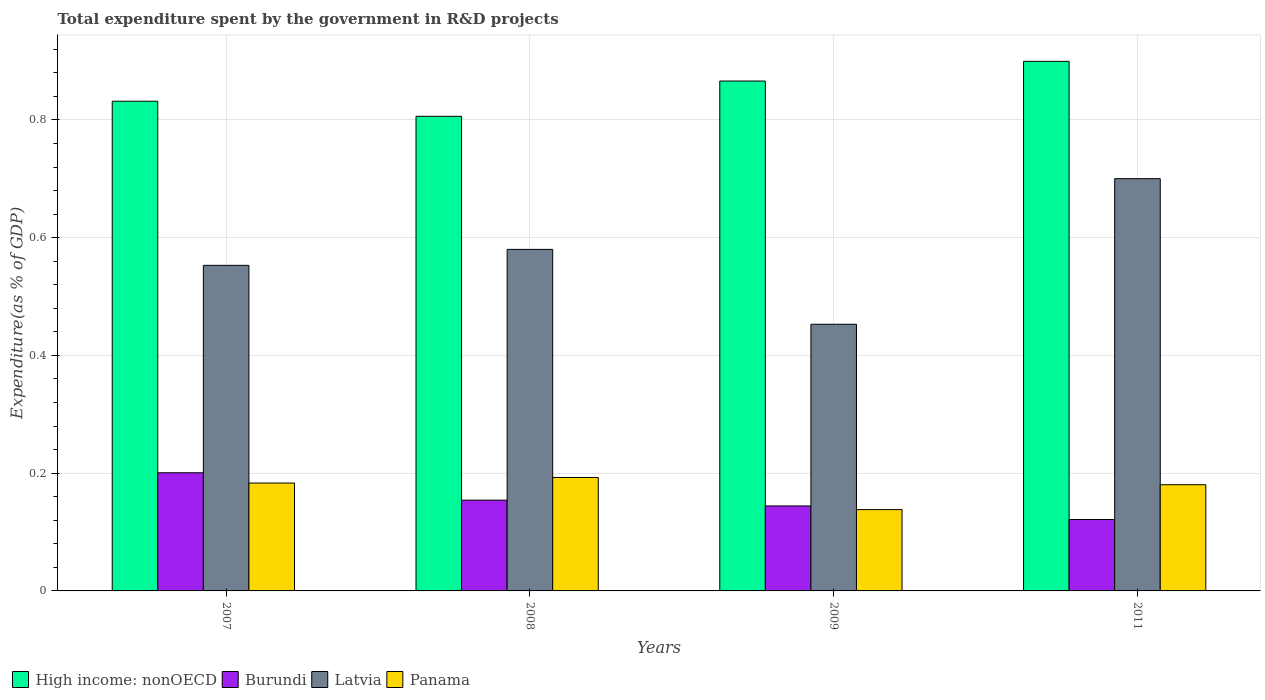Are the number of bars on each tick of the X-axis equal?
Your answer should be very brief. Yes. What is the label of the 1st group of bars from the left?
Give a very brief answer. 2007. What is the total expenditure spent by the government in R&D projects in Panama in 2007?
Your answer should be compact. 0.18. Across all years, what is the maximum total expenditure spent by the government in R&D projects in Latvia?
Your answer should be compact. 0.7. Across all years, what is the minimum total expenditure spent by the government in R&D projects in Panama?
Provide a succinct answer. 0.14. What is the total total expenditure spent by the government in R&D projects in Burundi in the graph?
Keep it short and to the point. 0.62. What is the difference between the total expenditure spent by the government in R&D projects in Panama in 2007 and that in 2011?
Provide a succinct answer. 0. What is the difference between the total expenditure spent by the government in R&D projects in High income: nonOECD in 2011 and the total expenditure spent by the government in R&D projects in Latvia in 2009?
Offer a very short reply. 0.45. What is the average total expenditure spent by the government in R&D projects in High income: nonOECD per year?
Offer a terse response. 0.85. In the year 2011, what is the difference between the total expenditure spent by the government in R&D projects in Burundi and total expenditure spent by the government in R&D projects in Latvia?
Offer a terse response. -0.58. What is the ratio of the total expenditure spent by the government in R&D projects in High income: nonOECD in 2007 to that in 2008?
Your answer should be very brief. 1.03. Is the total expenditure spent by the government in R&D projects in Latvia in 2007 less than that in 2009?
Give a very brief answer. No. What is the difference between the highest and the second highest total expenditure spent by the government in R&D projects in Latvia?
Ensure brevity in your answer.  0.12. What is the difference between the highest and the lowest total expenditure spent by the government in R&D projects in Panama?
Keep it short and to the point. 0.05. Is the sum of the total expenditure spent by the government in R&D projects in Latvia in 2009 and 2011 greater than the maximum total expenditure spent by the government in R&D projects in High income: nonOECD across all years?
Your response must be concise. Yes. Is it the case that in every year, the sum of the total expenditure spent by the government in R&D projects in High income: nonOECD and total expenditure spent by the government in R&D projects in Panama is greater than the sum of total expenditure spent by the government in R&D projects in Burundi and total expenditure spent by the government in R&D projects in Latvia?
Make the answer very short. No. What does the 2nd bar from the left in 2009 represents?
Provide a short and direct response. Burundi. What does the 4th bar from the right in 2011 represents?
Your answer should be very brief. High income: nonOECD. Are all the bars in the graph horizontal?
Offer a terse response. No. What is the difference between two consecutive major ticks on the Y-axis?
Offer a terse response. 0.2. Does the graph contain grids?
Provide a short and direct response. Yes. How many legend labels are there?
Offer a terse response. 4. What is the title of the graph?
Keep it short and to the point. Total expenditure spent by the government in R&D projects. What is the label or title of the Y-axis?
Keep it short and to the point. Expenditure(as % of GDP). What is the Expenditure(as % of GDP) in High income: nonOECD in 2007?
Make the answer very short. 0.83. What is the Expenditure(as % of GDP) of Burundi in 2007?
Keep it short and to the point. 0.2. What is the Expenditure(as % of GDP) of Latvia in 2007?
Make the answer very short. 0.55. What is the Expenditure(as % of GDP) in Panama in 2007?
Give a very brief answer. 0.18. What is the Expenditure(as % of GDP) in High income: nonOECD in 2008?
Your response must be concise. 0.81. What is the Expenditure(as % of GDP) of Burundi in 2008?
Your response must be concise. 0.15. What is the Expenditure(as % of GDP) in Latvia in 2008?
Make the answer very short. 0.58. What is the Expenditure(as % of GDP) in Panama in 2008?
Your response must be concise. 0.19. What is the Expenditure(as % of GDP) in High income: nonOECD in 2009?
Your answer should be compact. 0.87. What is the Expenditure(as % of GDP) of Burundi in 2009?
Ensure brevity in your answer.  0.14. What is the Expenditure(as % of GDP) of Latvia in 2009?
Your response must be concise. 0.45. What is the Expenditure(as % of GDP) in Panama in 2009?
Your answer should be compact. 0.14. What is the Expenditure(as % of GDP) in High income: nonOECD in 2011?
Give a very brief answer. 0.9. What is the Expenditure(as % of GDP) of Burundi in 2011?
Your answer should be compact. 0.12. What is the Expenditure(as % of GDP) of Latvia in 2011?
Ensure brevity in your answer.  0.7. What is the Expenditure(as % of GDP) in Panama in 2011?
Your response must be concise. 0.18. Across all years, what is the maximum Expenditure(as % of GDP) in High income: nonOECD?
Offer a terse response. 0.9. Across all years, what is the maximum Expenditure(as % of GDP) in Burundi?
Provide a succinct answer. 0.2. Across all years, what is the maximum Expenditure(as % of GDP) in Latvia?
Provide a short and direct response. 0.7. Across all years, what is the maximum Expenditure(as % of GDP) of Panama?
Offer a terse response. 0.19. Across all years, what is the minimum Expenditure(as % of GDP) of High income: nonOECD?
Give a very brief answer. 0.81. Across all years, what is the minimum Expenditure(as % of GDP) in Burundi?
Provide a short and direct response. 0.12. Across all years, what is the minimum Expenditure(as % of GDP) in Latvia?
Your answer should be compact. 0.45. Across all years, what is the minimum Expenditure(as % of GDP) of Panama?
Offer a terse response. 0.14. What is the total Expenditure(as % of GDP) in High income: nonOECD in the graph?
Offer a very short reply. 3.4. What is the total Expenditure(as % of GDP) of Burundi in the graph?
Make the answer very short. 0.62. What is the total Expenditure(as % of GDP) of Latvia in the graph?
Give a very brief answer. 2.29. What is the total Expenditure(as % of GDP) in Panama in the graph?
Make the answer very short. 0.69. What is the difference between the Expenditure(as % of GDP) in High income: nonOECD in 2007 and that in 2008?
Keep it short and to the point. 0.03. What is the difference between the Expenditure(as % of GDP) in Burundi in 2007 and that in 2008?
Ensure brevity in your answer.  0.05. What is the difference between the Expenditure(as % of GDP) of Latvia in 2007 and that in 2008?
Your response must be concise. -0.03. What is the difference between the Expenditure(as % of GDP) of Panama in 2007 and that in 2008?
Make the answer very short. -0.01. What is the difference between the Expenditure(as % of GDP) of High income: nonOECD in 2007 and that in 2009?
Provide a succinct answer. -0.03. What is the difference between the Expenditure(as % of GDP) in Burundi in 2007 and that in 2009?
Provide a short and direct response. 0.06. What is the difference between the Expenditure(as % of GDP) of Latvia in 2007 and that in 2009?
Provide a succinct answer. 0.1. What is the difference between the Expenditure(as % of GDP) in Panama in 2007 and that in 2009?
Make the answer very short. 0.05. What is the difference between the Expenditure(as % of GDP) in High income: nonOECD in 2007 and that in 2011?
Give a very brief answer. -0.07. What is the difference between the Expenditure(as % of GDP) of Burundi in 2007 and that in 2011?
Give a very brief answer. 0.08. What is the difference between the Expenditure(as % of GDP) in Latvia in 2007 and that in 2011?
Offer a very short reply. -0.15. What is the difference between the Expenditure(as % of GDP) of Panama in 2007 and that in 2011?
Provide a succinct answer. 0. What is the difference between the Expenditure(as % of GDP) in High income: nonOECD in 2008 and that in 2009?
Provide a succinct answer. -0.06. What is the difference between the Expenditure(as % of GDP) in Burundi in 2008 and that in 2009?
Provide a short and direct response. 0.01. What is the difference between the Expenditure(as % of GDP) of Latvia in 2008 and that in 2009?
Offer a terse response. 0.13. What is the difference between the Expenditure(as % of GDP) of Panama in 2008 and that in 2009?
Your response must be concise. 0.05. What is the difference between the Expenditure(as % of GDP) in High income: nonOECD in 2008 and that in 2011?
Your answer should be very brief. -0.09. What is the difference between the Expenditure(as % of GDP) of Burundi in 2008 and that in 2011?
Your answer should be very brief. 0.03. What is the difference between the Expenditure(as % of GDP) of Latvia in 2008 and that in 2011?
Your response must be concise. -0.12. What is the difference between the Expenditure(as % of GDP) of Panama in 2008 and that in 2011?
Your answer should be compact. 0.01. What is the difference between the Expenditure(as % of GDP) in High income: nonOECD in 2009 and that in 2011?
Provide a succinct answer. -0.03. What is the difference between the Expenditure(as % of GDP) in Burundi in 2009 and that in 2011?
Give a very brief answer. 0.02. What is the difference between the Expenditure(as % of GDP) in Latvia in 2009 and that in 2011?
Keep it short and to the point. -0.25. What is the difference between the Expenditure(as % of GDP) of Panama in 2009 and that in 2011?
Give a very brief answer. -0.04. What is the difference between the Expenditure(as % of GDP) in High income: nonOECD in 2007 and the Expenditure(as % of GDP) in Burundi in 2008?
Offer a terse response. 0.68. What is the difference between the Expenditure(as % of GDP) of High income: nonOECD in 2007 and the Expenditure(as % of GDP) of Latvia in 2008?
Offer a terse response. 0.25. What is the difference between the Expenditure(as % of GDP) of High income: nonOECD in 2007 and the Expenditure(as % of GDP) of Panama in 2008?
Your answer should be very brief. 0.64. What is the difference between the Expenditure(as % of GDP) in Burundi in 2007 and the Expenditure(as % of GDP) in Latvia in 2008?
Your answer should be compact. -0.38. What is the difference between the Expenditure(as % of GDP) in Burundi in 2007 and the Expenditure(as % of GDP) in Panama in 2008?
Offer a terse response. 0.01. What is the difference between the Expenditure(as % of GDP) of Latvia in 2007 and the Expenditure(as % of GDP) of Panama in 2008?
Your answer should be very brief. 0.36. What is the difference between the Expenditure(as % of GDP) in High income: nonOECD in 2007 and the Expenditure(as % of GDP) in Burundi in 2009?
Your answer should be compact. 0.69. What is the difference between the Expenditure(as % of GDP) in High income: nonOECD in 2007 and the Expenditure(as % of GDP) in Latvia in 2009?
Give a very brief answer. 0.38. What is the difference between the Expenditure(as % of GDP) of High income: nonOECD in 2007 and the Expenditure(as % of GDP) of Panama in 2009?
Your answer should be compact. 0.69. What is the difference between the Expenditure(as % of GDP) in Burundi in 2007 and the Expenditure(as % of GDP) in Latvia in 2009?
Offer a very short reply. -0.25. What is the difference between the Expenditure(as % of GDP) of Burundi in 2007 and the Expenditure(as % of GDP) of Panama in 2009?
Your answer should be very brief. 0.06. What is the difference between the Expenditure(as % of GDP) of Latvia in 2007 and the Expenditure(as % of GDP) of Panama in 2009?
Provide a short and direct response. 0.41. What is the difference between the Expenditure(as % of GDP) in High income: nonOECD in 2007 and the Expenditure(as % of GDP) in Burundi in 2011?
Offer a terse response. 0.71. What is the difference between the Expenditure(as % of GDP) of High income: nonOECD in 2007 and the Expenditure(as % of GDP) of Latvia in 2011?
Provide a short and direct response. 0.13. What is the difference between the Expenditure(as % of GDP) of High income: nonOECD in 2007 and the Expenditure(as % of GDP) of Panama in 2011?
Make the answer very short. 0.65. What is the difference between the Expenditure(as % of GDP) of Burundi in 2007 and the Expenditure(as % of GDP) of Latvia in 2011?
Ensure brevity in your answer.  -0.5. What is the difference between the Expenditure(as % of GDP) in Burundi in 2007 and the Expenditure(as % of GDP) in Panama in 2011?
Make the answer very short. 0.02. What is the difference between the Expenditure(as % of GDP) of Latvia in 2007 and the Expenditure(as % of GDP) of Panama in 2011?
Keep it short and to the point. 0.37. What is the difference between the Expenditure(as % of GDP) of High income: nonOECD in 2008 and the Expenditure(as % of GDP) of Burundi in 2009?
Ensure brevity in your answer.  0.66. What is the difference between the Expenditure(as % of GDP) of High income: nonOECD in 2008 and the Expenditure(as % of GDP) of Latvia in 2009?
Provide a succinct answer. 0.35. What is the difference between the Expenditure(as % of GDP) in High income: nonOECD in 2008 and the Expenditure(as % of GDP) in Panama in 2009?
Provide a short and direct response. 0.67. What is the difference between the Expenditure(as % of GDP) in Burundi in 2008 and the Expenditure(as % of GDP) in Latvia in 2009?
Ensure brevity in your answer.  -0.3. What is the difference between the Expenditure(as % of GDP) in Burundi in 2008 and the Expenditure(as % of GDP) in Panama in 2009?
Your answer should be very brief. 0.02. What is the difference between the Expenditure(as % of GDP) of Latvia in 2008 and the Expenditure(as % of GDP) of Panama in 2009?
Your answer should be compact. 0.44. What is the difference between the Expenditure(as % of GDP) in High income: nonOECD in 2008 and the Expenditure(as % of GDP) in Burundi in 2011?
Your answer should be compact. 0.68. What is the difference between the Expenditure(as % of GDP) in High income: nonOECD in 2008 and the Expenditure(as % of GDP) in Latvia in 2011?
Provide a short and direct response. 0.11. What is the difference between the Expenditure(as % of GDP) in High income: nonOECD in 2008 and the Expenditure(as % of GDP) in Panama in 2011?
Your answer should be compact. 0.63. What is the difference between the Expenditure(as % of GDP) of Burundi in 2008 and the Expenditure(as % of GDP) of Latvia in 2011?
Give a very brief answer. -0.55. What is the difference between the Expenditure(as % of GDP) of Burundi in 2008 and the Expenditure(as % of GDP) of Panama in 2011?
Keep it short and to the point. -0.03. What is the difference between the Expenditure(as % of GDP) of Latvia in 2008 and the Expenditure(as % of GDP) of Panama in 2011?
Ensure brevity in your answer.  0.4. What is the difference between the Expenditure(as % of GDP) of High income: nonOECD in 2009 and the Expenditure(as % of GDP) of Burundi in 2011?
Your response must be concise. 0.74. What is the difference between the Expenditure(as % of GDP) in High income: nonOECD in 2009 and the Expenditure(as % of GDP) in Latvia in 2011?
Your answer should be very brief. 0.17. What is the difference between the Expenditure(as % of GDP) of High income: nonOECD in 2009 and the Expenditure(as % of GDP) of Panama in 2011?
Your response must be concise. 0.69. What is the difference between the Expenditure(as % of GDP) of Burundi in 2009 and the Expenditure(as % of GDP) of Latvia in 2011?
Offer a terse response. -0.56. What is the difference between the Expenditure(as % of GDP) in Burundi in 2009 and the Expenditure(as % of GDP) in Panama in 2011?
Provide a succinct answer. -0.04. What is the difference between the Expenditure(as % of GDP) of Latvia in 2009 and the Expenditure(as % of GDP) of Panama in 2011?
Your answer should be very brief. 0.27. What is the average Expenditure(as % of GDP) of High income: nonOECD per year?
Give a very brief answer. 0.85. What is the average Expenditure(as % of GDP) of Burundi per year?
Provide a succinct answer. 0.16. What is the average Expenditure(as % of GDP) in Latvia per year?
Offer a terse response. 0.57. What is the average Expenditure(as % of GDP) of Panama per year?
Offer a terse response. 0.17. In the year 2007, what is the difference between the Expenditure(as % of GDP) in High income: nonOECD and Expenditure(as % of GDP) in Burundi?
Keep it short and to the point. 0.63. In the year 2007, what is the difference between the Expenditure(as % of GDP) of High income: nonOECD and Expenditure(as % of GDP) of Latvia?
Provide a succinct answer. 0.28. In the year 2007, what is the difference between the Expenditure(as % of GDP) in High income: nonOECD and Expenditure(as % of GDP) in Panama?
Your answer should be very brief. 0.65. In the year 2007, what is the difference between the Expenditure(as % of GDP) of Burundi and Expenditure(as % of GDP) of Latvia?
Provide a succinct answer. -0.35. In the year 2007, what is the difference between the Expenditure(as % of GDP) in Burundi and Expenditure(as % of GDP) in Panama?
Make the answer very short. 0.02. In the year 2007, what is the difference between the Expenditure(as % of GDP) in Latvia and Expenditure(as % of GDP) in Panama?
Keep it short and to the point. 0.37. In the year 2008, what is the difference between the Expenditure(as % of GDP) in High income: nonOECD and Expenditure(as % of GDP) in Burundi?
Keep it short and to the point. 0.65. In the year 2008, what is the difference between the Expenditure(as % of GDP) in High income: nonOECD and Expenditure(as % of GDP) in Latvia?
Make the answer very short. 0.23. In the year 2008, what is the difference between the Expenditure(as % of GDP) of High income: nonOECD and Expenditure(as % of GDP) of Panama?
Keep it short and to the point. 0.61. In the year 2008, what is the difference between the Expenditure(as % of GDP) in Burundi and Expenditure(as % of GDP) in Latvia?
Your answer should be very brief. -0.43. In the year 2008, what is the difference between the Expenditure(as % of GDP) of Burundi and Expenditure(as % of GDP) of Panama?
Provide a succinct answer. -0.04. In the year 2008, what is the difference between the Expenditure(as % of GDP) of Latvia and Expenditure(as % of GDP) of Panama?
Your response must be concise. 0.39. In the year 2009, what is the difference between the Expenditure(as % of GDP) in High income: nonOECD and Expenditure(as % of GDP) in Burundi?
Offer a terse response. 0.72. In the year 2009, what is the difference between the Expenditure(as % of GDP) of High income: nonOECD and Expenditure(as % of GDP) of Latvia?
Offer a terse response. 0.41. In the year 2009, what is the difference between the Expenditure(as % of GDP) of High income: nonOECD and Expenditure(as % of GDP) of Panama?
Offer a terse response. 0.73. In the year 2009, what is the difference between the Expenditure(as % of GDP) of Burundi and Expenditure(as % of GDP) of Latvia?
Make the answer very short. -0.31. In the year 2009, what is the difference between the Expenditure(as % of GDP) in Burundi and Expenditure(as % of GDP) in Panama?
Provide a succinct answer. 0.01. In the year 2009, what is the difference between the Expenditure(as % of GDP) in Latvia and Expenditure(as % of GDP) in Panama?
Give a very brief answer. 0.31. In the year 2011, what is the difference between the Expenditure(as % of GDP) of High income: nonOECD and Expenditure(as % of GDP) of Burundi?
Keep it short and to the point. 0.78. In the year 2011, what is the difference between the Expenditure(as % of GDP) of High income: nonOECD and Expenditure(as % of GDP) of Latvia?
Your answer should be very brief. 0.2. In the year 2011, what is the difference between the Expenditure(as % of GDP) in High income: nonOECD and Expenditure(as % of GDP) in Panama?
Make the answer very short. 0.72. In the year 2011, what is the difference between the Expenditure(as % of GDP) of Burundi and Expenditure(as % of GDP) of Latvia?
Offer a terse response. -0.58. In the year 2011, what is the difference between the Expenditure(as % of GDP) of Burundi and Expenditure(as % of GDP) of Panama?
Ensure brevity in your answer.  -0.06. In the year 2011, what is the difference between the Expenditure(as % of GDP) of Latvia and Expenditure(as % of GDP) of Panama?
Your answer should be compact. 0.52. What is the ratio of the Expenditure(as % of GDP) of High income: nonOECD in 2007 to that in 2008?
Give a very brief answer. 1.03. What is the ratio of the Expenditure(as % of GDP) of Burundi in 2007 to that in 2008?
Offer a terse response. 1.3. What is the ratio of the Expenditure(as % of GDP) of Latvia in 2007 to that in 2008?
Give a very brief answer. 0.95. What is the ratio of the Expenditure(as % of GDP) of Panama in 2007 to that in 2008?
Provide a short and direct response. 0.95. What is the ratio of the Expenditure(as % of GDP) in High income: nonOECD in 2007 to that in 2009?
Offer a terse response. 0.96. What is the ratio of the Expenditure(as % of GDP) in Burundi in 2007 to that in 2009?
Your answer should be compact. 1.39. What is the ratio of the Expenditure(as % of GDP) of Latvia in 2007 to that in 2009?
Provide a succinct answer. 1.22. What is the ratio of the Expenditure(as % of GDP) of Panama in 2007 to that in 2009?
Offer a terse response. 1.33. What is the ratio of the Expenditure(as % of GDP) in High income: nonOECD in 2007 to that in 2011?
Give a very brief answer. 0.92. What is the ratio of the Expenditure(as % of GDP) in Burundi in 2007 to that in 2011?
Give a very brief answer. 1.66. What is the ratio of the Expenditure(as % of GDP) of Latvia in 2007 to that in 2011?
Ensure brevity in your answer.  0.79. What is the ratio of the Expenditure(as % of GDP) of Panama in 2007 to that in 2011?
Offer a very short reply. 1.02. What is the ratio of the Expenditure(as % of GDP) in High income: nonOECD in 2008 to that in 2009?
Give a very brief answer. 0.93. What is the ratio of the Expenditure(as % of GDP) in Burundi in 2008 to that in 2009?
Offer a terse response. 1.07. What is the ratio of the Expenditure(as % of GDP) of Latvia in 2008 to that in 2009?
Provide a succinct answer. 1.28. What is the ratio of the Expenditure(as % of GDP) of Panama in 2008 to that in 2009?
Make the answer very short. 1.39. What is the ratio of the Expenditure(as % of GDP) in High income: nonOECD in 2008 to that in 2011?
Keep it short and to the point. 0.9. What is the ratio of the Expenditure(as % of GDP) in Burundi in 2008 to that in 2011?
Ensure brevity in your answer.  1.27. What is the ratio of the Expenditure(as % of GDP) in Latvia in 2008 to that in 2011?
Ensure brevity in your answer.  0.83. What is the ratio of the Expenditure(as % of GDP) in Panama in 2008 to that in 2011?
Your response must be concise. 1.07. What is the ratio of the Expenditure(as % of GDP) of High income: nonOECD in 2009 to that in 2011?
Give a very brief answer. 0.96. What is the ratio of the Expenditure(as % of GDP) of Burundi in 2009 to that in 2011?
Your answer should be compact. 1.19. What is the ratio of the Expenditure(as % of GDP) of Latvia in 2009 to that in 2011?
Keep it short and to the point. 0.65. What is the ratio of the Expenditure(as % of GDP) in Panama in 2009 to that in 2011?
Provide a short and direct response. 0.77. What is the difference between the highest and the second highest Expenditure(as % of GDP) in High income: nonOECD?
Your response must be concise. 0.03. What is the difference between the highest and the second highest Expenditure(as % of GDP) of Burundi?
Your answer should be compact. 0.05. What is the difference between the highest and the second highest Expenditure(as % of GDP) in Latvia?
Provide a succinct answer. 0.12. What is the difference between the highest and the second highest Expenditure(as % of GDP) in Panama?
Make the answer very short. 0.01. What is the difference between the highest and the lowest Expenditure(as % of GDP) in High income: nonOECD?
Provide a succinct answer. 0.09. What is the difference between the highest and the lowest Expenditure(as % of GDP) of Burundi?
Provide a short and direct response. 0.08. What is the difference between the highest and the lowest Expenditure(as % of GDP) in Latvia?
Your answer should be compact. 0.25. What is the difference between the highest and the lowest Expenditure(as % of GDP) in Panama?
Make the answer very short. 0.05. 